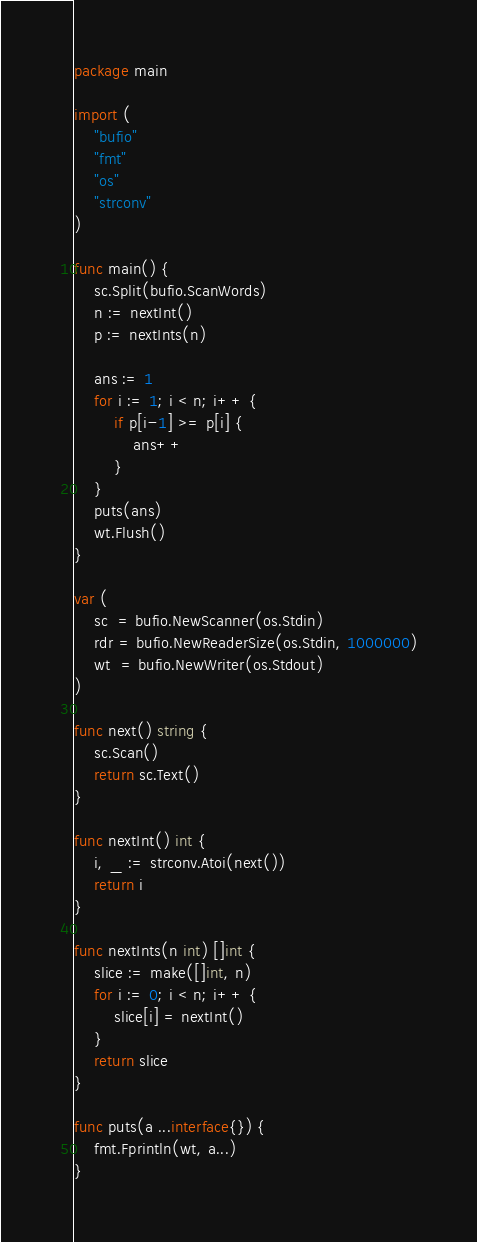Convert code to text. <code><loc_0><loc_0><loc_500><loc_500><_Go_>package main

import (
	"bufio"
	"fmt"
	"os"
	"strconv"
)

func main() {
	sc.Split(bufio.ScanWords)
	n := nextInt()
	p := nextInts(n)

	ans := 1
	for i := 1; i < n; i++ {
		if p[i-1] >= p[i] {
			ans++
		}
	}
	puts(ans)
	wt.Flush()
}

var (
	sc  = bufio.NewScanner(os.Stdin)
	rdr = bufio.NewReaderSize(os.Stdin, 1000000)
	wt  = bufio.NewWriter(os.Stdout)
)

func next() string {
	sc.Scan()
	return sc.Text()
}

func nextInt() int {
	i, _ := strconv.Atoi(next())
	return i
}

func nextInts(n int) []int {
	slice := make([]int, n)
	for i := 0; i < n; i++ {
		slice[i] = nextInt()
	}
	return slice
}

func puts(a ...interface{}) {
	fmt.Fprintln(wt, a...)
}
</code> 